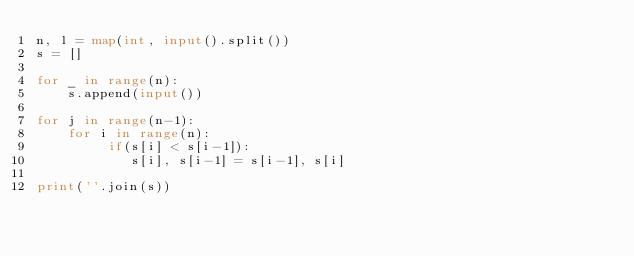Convert code to text. <code><loc_0><loc_0><loc_500><loc_500><_Python_>n, l = map(int, input().split())
s = []

for _ in range(n):
    s.append(input())

for j in range(n-1):    
    for i in range(n):
         if(s[i] < s[i-1]):
            s[i], s[i-1] = s[i-1], s[i]

print(''.join(s))</code> 